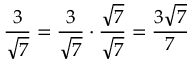Convert formula to latex. <formula><loc_0><loc_0><loc_500><loc_500>{ \frac { 3 } { \sqrt { 7 } } } = { \frac { 3 } { \sqrt { 7 } } } \cdot { \frac { \sqrt { 7 } } { \sqrt { 7 } } } = { \frac { 3 { \sqrt { 7 } } } { 7 } }</formula> 